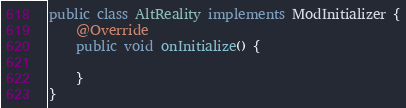Convert code to text. <code><loc_0><loc_0><loc_500><loc_500><_Java_>public class AltReality implements ModInitializer {
	@Override
	public void onInitialize() {

	}
}
</code> 